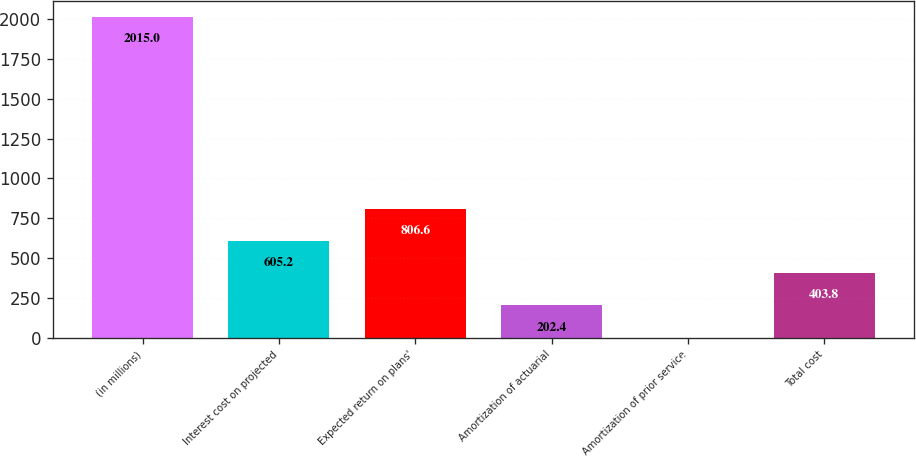<chart> <loc_0><loc_0><loc_500><loc_500><bar_chart><fcel>(in millions)<fcel>Interest cost on projected<fcel>Expected return on plans'<fcel>Amortization of actuarial<fcel>Amortization of prior service<fcel>Total cost<nl><fcel>2015<fcel>605.2<fcel>806.6<fcel>202.4<fcel>1<fcel>403.8<nl></chart> 